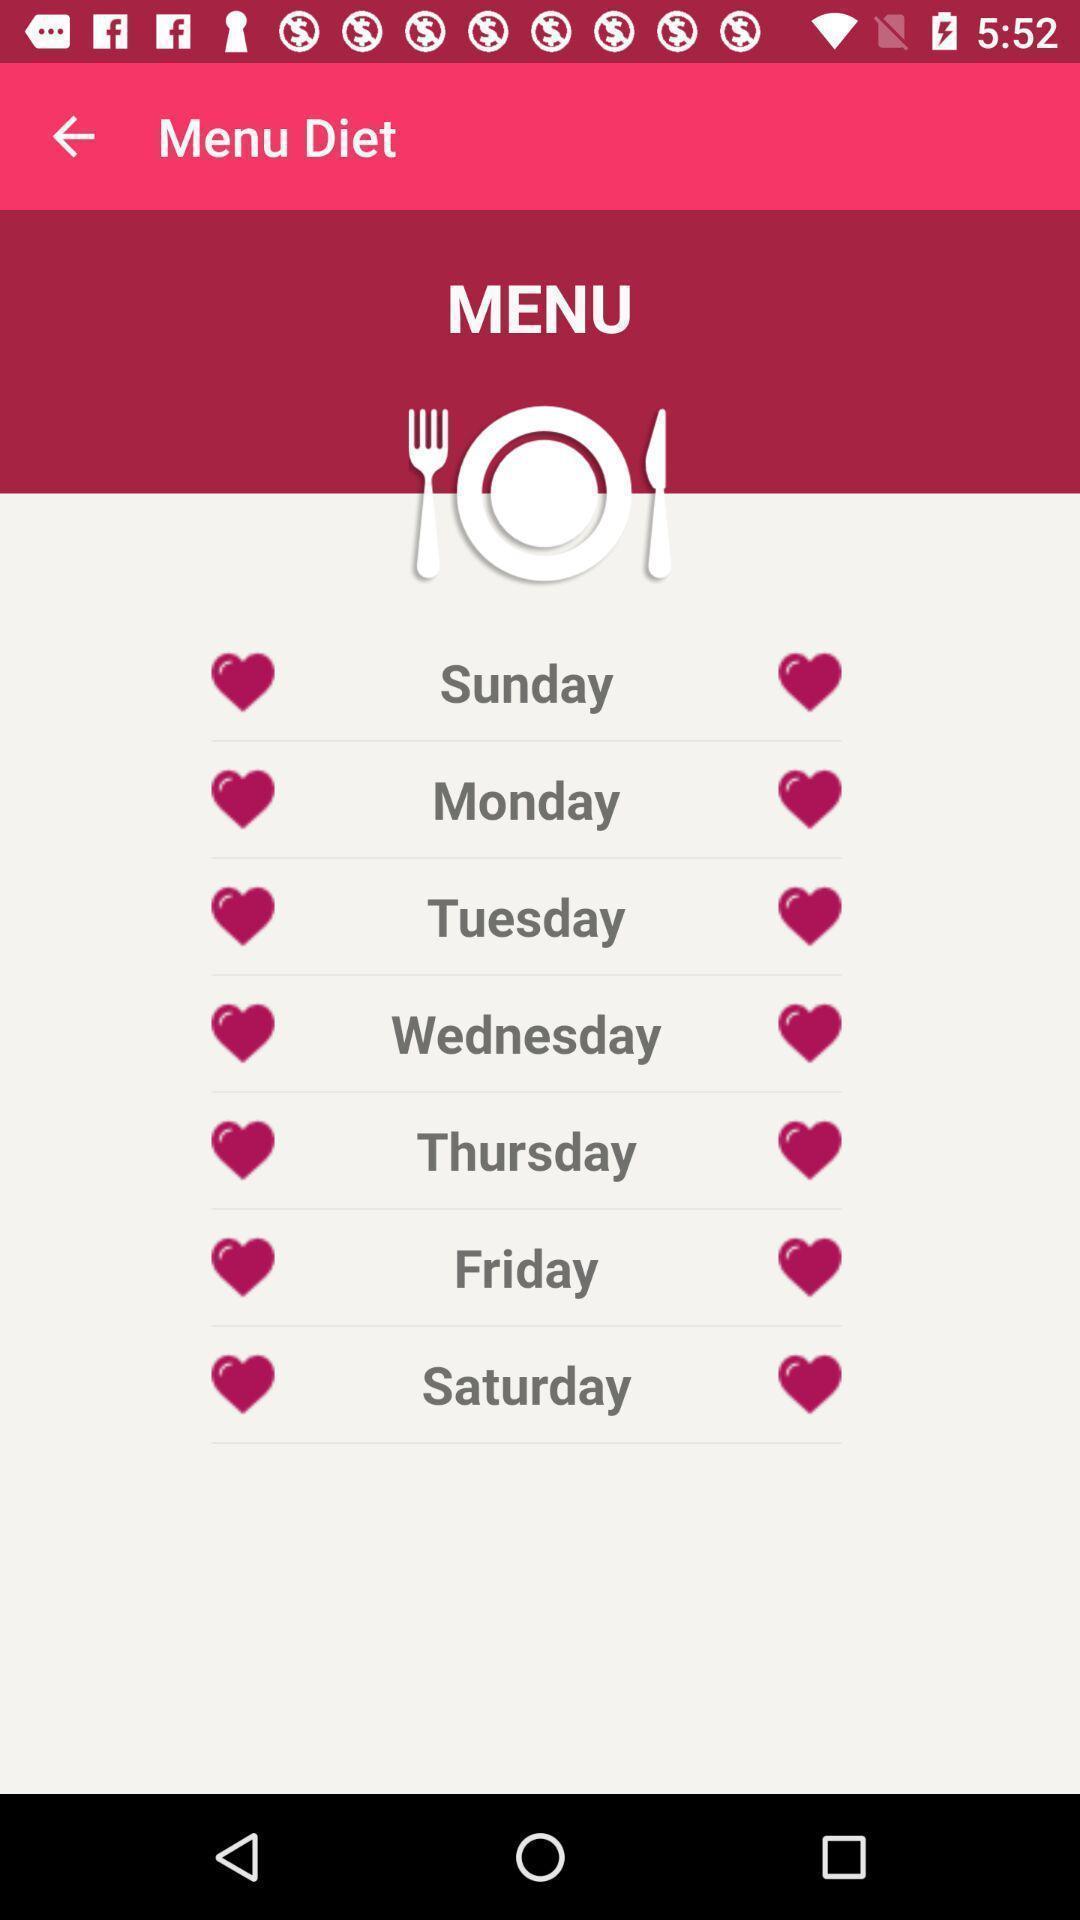Tell me about the visual elements in this screen capture. Screen shows menu details in a food app. 